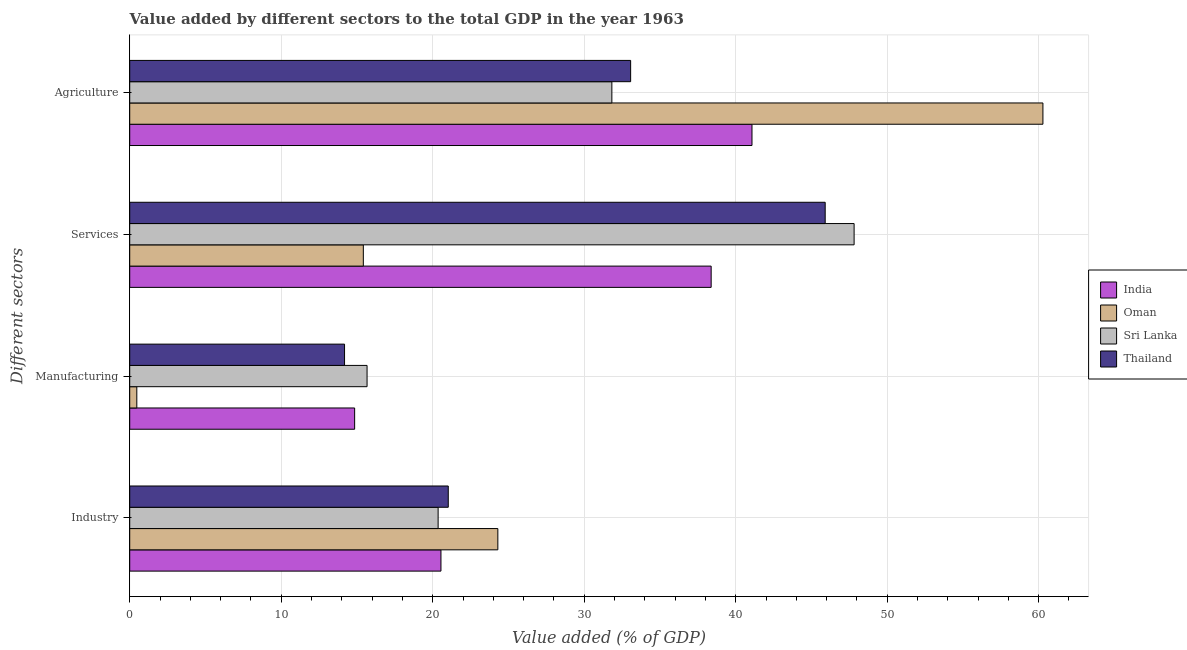How many different coloured bars are there?
Provide a short and direct response. 4. Are the number of bars on each tick of the Y-axis equal?
Give a very brief answer. Yes. How many bars are there on the 4th tick from the top?
Provide a succinct answer. 4. What is the label of the 1st group of bars from the top?
Your response must be concise. Agriculture. What is the value added by manufacturing sector in Thailand?
Keep it short and to the point. 14.18. Across all countries, what is the maximum value added by services sector?
Make the answer very short. 47.82. Across all countries, what is the minimum value added by manufacturing sector?
Your answer should be very brief. 0.47. In which country was the value added by industrial sector maximum?
Your response must be concise. Oman. In which country was the value added by agricultural sector minimum?
Offer a very short reply. Sri Lanka. What is the total value added by manufacturing sector in the graph?
Offer a terse response. 45.16. What is the difference between the value added by industrial sector in India and that in Oman?
Keep it short and to the point. -3.76. What is the difference between the value added by services sector in Thailand and the value added by industrial sector in India?
Your response must be concise. 25.36. What is the average value added by services sector per country?
Keep it short and to the point. 36.88. What is the difference between the value added by manufacturing sector and value added by industrial sector in India?
Your response must be concise. -5.7. What is the ratio of the value added by industrial sector in Thailand to that in Oman?
Provide a short and direct response. 0.87. Is the value added by services sector in Thailand less than that in India?
Offer a very short reply. No. Is the difference between the value added by industrial sector in Thailand and Oman greater than the difference between the value added by services sector in Thailand and Oman?
Make the answer very short. No. What is the difference between the highest and the second highest value added by services sector?
Your response must be concise. 1.91. What is the difference between the highest and the lowest value added by industrial sector?
Give a very brief answer. 3.94. Is it the case that in every country, the sum of the value added by manufacturing sector and value added by industrial sector is greater than the sum of value added by services sector and value added by agricultural sector?
Your response must be concise. No. What does the 3rd bar from the top in Agriculture represents?
Keep it short and to the point. Oman. What does the 3rd bar from the bottom in Agriculture represents?
Keep it short and to the point. Sri Lanka. How many bars are there?
Make the answer very short. 16. Are all the bars in the graph horizontal?
Offer a terse response. Yes. Are the values on the major ticks of X-axis written in scientific E-notation?
Provide a short and direct response. No. Does the graph contain any zero values?
Provide a short and direct response. No. Does the graph contain grids?
Make the answer very short. Yes. How are the legend labels stacked?
Give a very brief answer. Vertical. What is the title of the graph?
Provide a short and direct response. Value added by different sectors to the total GDP in the year 1963. What is the label or title of the X-axis?
Ensure brevity in your answer.  Value added (% of GDP). What is the label or title of the Y-axis?
Offer a terse response. Different sectors. What is the Value added (% of GDP) in India in Industry?
Provide a succinct answer. 20.54. What is the Value added (% of GDP) in Oman in Industry?
Provide a short and direct response. 24.3. What is the Value added (% of GDP) of Sri Lanka in Industry?
Offer a terse response. 20.36. What is the Value added (% of GDP) in Thailand in Industry?
Make the answer very short. 21.03. What is the Value added (% of GDP) in India in Manufacturing?
Provide a succinct answer. 14.85. What is the Value added (% of GDP) of Oman in Manufacturing?
Your answer should be very brief. 0.47. What is the Value added (% of GDP) in Sri Lanka in Manufacturing?
Your answer should be compact. 15.67. What is the Value added (% of GDP) of Thailand in Manufacturing?
Your answer should be compact. 14.18. What is the Value added (% of GDP) in India in Services?
Your answer should be compact. 38.38. What is the Value added (% of GDP) of Oman in Services?
Keep it short and to the point. 15.42. What is the Value added (% of GDP) of Sri Lanka in Services?
Offer a very short reply. 47.82. What is the Value added (% of GDP) of Thailand in Services?
Your answer should be compact. 45.91. What is the Value added (% of GDP) of India in Agriculture?
Keep it short and to the point. 41.08. What is the Value added (% of GDP) of Oman in Agriculture?
Offer a terse response. 60.28. What is the Value added (% of GDP) in Sri Lanka in Agriculture?
Offer a very short reply. 31.83. What is the Value added (% of GDP) of Thailand in Agriculture?
Your answer should be very brief. 33.07. Across all Different sectors, what is the maximum Value added (% of GDP) of India?
Offer a terse response. 41.08. Across all Different sectors, what is the maximum Value added (% of GDP) in Oman?
Make the answer very short. 60.28. Across all Different sectors, what is the maximum Value added (% of GDP) in Sri Lanka?
Your answer should be compact. 47.82. Across all Different sectors, what is the maximum Value added (% of GDP) of Thailand?
Give a very brief answer. 45.91. Across all Different sectors, what is the minimum Value added (% of GDP) in India?
Ensure brevity in your answer.  14.85. Across all Different sectors, what is the minimum Value added (% of GDP) in Oman?
Provide a succinct answer. 0.47. Across all Different sectors, what is the minimum Value added (% of GDP) in Sri Lanka?
Ensure brevity in your answer.  15.67. Across all Different sectors, what is the minimum Value added (% of GDP) in Thailand?
Give a very brief answer. 14.18. What is the total Value added (% of GDP) in India in the graph?
Your response must be concise. 114.85. What is the total Value added (% of GDP) of Oman in the graph?
Offer a very short reply. 100.47. What is the total Value added (% of GDP) of Sri Lanka in the graph?
Offer a terse response. 115.67. What is the total Value added (% of GDP) in Thailand in the graph?
Provide a succinct answer. 114.18. What is the difference between the Value added (% of GDP) of India in Industry and that in Manufacturing?
Provide a succinct answer. 5.7. What is the difference between the Value added (% of GDP) of Oman in Industry and that in Manufacturing?
Provide a succinct answer. 23.83. What is the difference between the Value added (% of GDP) in Sri Lanka in Industry and that in Manufacturing?
Ensure brevity in your answer.  4.69. What is the difference between the Value added (% of GDP) in Thailand in Industry and that in Manufacturing?
Provide a succinct answer. 6.85. What is the difference between the Value added (% of GDP) of India in Industry and that in Services?
Your answer should be very brief. -17.84. What is the difference between the Value added (% of GDP) in Oman in Industry and that in Services?
Your answer should be very brief. 8.88. What is the difference between the Value added (% of GDP) in Sri Lanka in Industry and that in Services?
Ensure brevity in your answer.  -27.46. What is the difference between the Value added (% of GDP) in Thailand in Industry and that in Services?
Provide a short and direct response. -24.88. What is the difference between the Value added (% of GDP) of India in Industry and that in Agriculture?
Keep it short and to the point. -20.53. What is the difference between the Value added (% of GDP) in Oman in Industry and that in Agriculture?
Your response must be concise. -35.98. What is the difference between the Value added (% of GDP) of Sri Lanka in Industry and that in Agriculture?
Provide a short and direct response. -11.47. What is the difference between the Value added (% of GDP) in Thailand in Industry and that in Agriculture?
Make the answer very short. -12.04. What is the difference between the Value added (% of GDP) of India in Manufacturing and that in Services?
Make the answer very short. -23.53. What is the difference between the Value added (% of GDP) of Oman in Manufacturing and that in Services?
Make the answer very short. -14.95. What is the difference between the Value added (% of GDP) in Sri Lanka in Manufacturing and that in Services?
Give a very brief answer. -32.15. What is the difference between the Value added (% of GDP) in Thailand in Manufacturing and that in Services?
Give a very brief answer. -31.73. What is the difference between the Value added (% of GDP) in India in Manufacturing and that in Agriculture?
Give a very brief answer. -26.23. What is the difference between the Value added (% of GDP) of Oman in Manufacturing and that in Agriculture?
Ensure brevity in your answer.  -59.81. What is the difference between the Value added (% of GDP) in Sri Lanka in Manufacturing and that in Agriculture?
Your answer should be compact. -16.16. What is the difference between the Value added (% of GDP) in Thailand in Manufacturing and that in Agriculture?
Make the answer very short. -18.88. What is the difference between the Value added (% of GDP) of India in Services and that in Agriculture?
Offer a terse response. -2.7. What is the difference between the Value added (% of GDP) in Oman in Services and that in Agriculture?
Make the answer very short. -44.86. What is the difference between the Value added (% of GDP) of Sri Lanka in Services and that in Agriculture?
Your response must be concise. 15.99. What is the difference between the Value added (% of GDP) of Thailand in Services and that in Agriculture?
Give a very brief answer. 12.84. What is the difference between the Value added (% of GDP) of India in Industry and the Value added (% of GDP) of Oman in Manufacturing?
Ensure brevity in your answer.  20.08. What is the difference between the Value added (% of GDP) of India in Industry and the Value added (% of GDP) of Sri Lanka in Manufacturing?
Your answer should be compact. 4.88. What is the difference between the Value added (% of GDP) of India in Industry and the Value added (% of GDP) of Thailand in Manufacturing?
Give a very brief answer. 6.36. What is the difference between the Value added (% of GDP) in Oman in Industry and the Value added (% of GDP) in Sri Lanka in Manufacturing?
Make the answer very short. 8.63. What is the difference between the Value added (% of GDP) of Oman in Industry and the Value added (% of GDP) of Thailand in Manufacturing?
Your answer should be very brief. 10.12. What is the difference between the Value added (% of GDP) in Sri Lanka in Industry and the Value added (% of GDP) in Thailand in Manufacturing?
Offer a very short reply. 6.18. What is the difference between the Value added (% of GDP) of India in Industry and the Value added (% of GDP) of Oman in Services?
Offer a terse response. 5.12. What is the difference between the Value added (% of GDP) of India in Industry and the Value added (% of GDP) of Sri Lanka in Services?
Your response must be concise. -27.27. What is the difference between the Value added (% of GDP) in India in Industry and the Value added (% of GDP) in Thailand in Services?
Your answer should be very brief. -25.36. What is the difference between the Value added (% of GDP) of Oman in Industry and the Value added (% of GDP) of Sri Lanka in Services?
Provide a succinct answer. -23.52. What is the difference between the Value added (% of GDP) in Oman in Industry and the Value added (% of GDP) in Thailand in Services?
Give a very brief answer. -21.61. What is the difference between the Value added (% of GDP) of Sri Lanka in Industry and the Value added (% of GDP) of Thailand in Services?
Your response must be concise. -25.55. What is the difference between the Value added (% of GDP) in India in Industry and the Value added (% of GDP) in Oman in Agriculture?
Your answer should be very brief. -39.74. What is the difference between the Value added (% of GDP) in India in Industry and the Value added (% of GDP) in Sri Lanka in Agriculture?
Your answer should be very brief. -11.28. What is the difference between the Value added (% of GDP) of India in Industry and the Value added (% of GDP) of Thailand in Agriculture?
Keep it short and to the point. -12.52. What is the difference between the Value added (% of GDP) in Oman in Industry and the Value added (% of GDP) in Sri Lanka in Agriculture?
Make the answer very short. -7.53. What is the difference between the Value added (% of GDP) in Oman in Industry and the Value added (% of GDP) in Thailand in Agriculture?
Ensure brevity in your answer.  -8.77. What is the difference between the Value added (% of GDP) in Sri Lanka in Industry and the Value added (% of GDP) in Thailand in Agriculture?
Your answer should be very brief. -12.71. What is the difference between the Value added (% of GDP) of India in Manufacturing and the Value added (% of GDP) of Oman in Services?
Give a very brief answer. -0.57. What is the difference between the Value added (% of GDP) of India in Manufacturing and the Value added (% of GDP) of Sri Lanka in Services?
Provide a succinct answer. -32.97. What is the difference between the Value added (% of GDP) in India in Manufacturing and the Value added (% of GDP) in Thailand in Services?
Your response must be concise. -31.06. What is the difference between the Value added (% of GDP) in Oman in Manufacturing and the Value added (% of GDP) in Sri Lanka in Services?
Offer a terse response. -47.35. What is the difference between the Value added (% of GDP) in Oman in Manufacturing and the Value added (% of GDP) in Thailand in Services?
Offer a terse response. -45.44. What is the difference between the Value added (% of GDP) in Sri Lanka in Manufacturing and the Value added (% of GDP) in Thailand in Services?
Your answer should be very brief. -30.24. What is the difference between the Value added (% of GDP) in India in Manufacturing and the Value added (% of GDP) in Oman in Agriculture?
Offer a terse response. -45.43. What is the difference between the Value added (% of GDP) in India in Manufacturing and the Value added (% of GDP) in Sri Lanka in Agriculture?
Provide a succinct answer. -16.98. What is the difference between the Value added (% of GDP) in India in Manufacturing and the Value added (% of GDP) in Thailand in Agriculture?
Give a very brief answer. -18.22. What is the difference between the Value added (% of GDP) in Oman in Manufacturing and the Value added (% of GDP) in Sri Lanka in Agriculture?
Offer a very short reply. -31.36. What is the difference between the Value added (% of GDP) of Oman in Manufacturing and the Value added (% of GDP) of Thailand in Agriculture?
Offer a very short reply. -32.6. What is the difference between the Value added (% of GDP) in Sri Lanka in Manufacturing and the Value added (% of GDP) in Thailand in Agriculture?
Make the answer very short. -17.4. What is the difference between the Value added (% of GDP) in India in Services and the Value added (% of GDP) in Oman in Agriculture?
Provide a succinct answer. -21.9. What is the difference between the Value added (% of GDP) in India in Services and the Value added (% of GDP) in Sri Lanka in Agriculture?
Keep it short and to the point. 6.55. What is the difference between the Value added (% of GDP) of India in Services and the Value added (% of GDP) of Thailand in Agriculture?
Your answer should be compact. 5.32. What is the difference between the Value added (% of GDP) of Oman in Services and the Value added (% of GDP) of Sri Lanka in Agriculture?
Offer a very short reply. -16.41. What is the difference between the Value added (% of GDP) in Oman in Services and the Value added (% of GDP) in Thailand in Agriculture?
Offer a terse response. -17.64. What is the difference between the Value added (% of GDP) in Sri Lanka in Services and the Value added (% of GDP) in Thailand in Agriculture?
Your answer should be compact. 14.75. What is the average Value added (% of GDP) of India per Different sectors?
Keep it short and to the point. 28.71. What is the average Value added (% of GDP) of Oman per Different sectors?
Your answer should be compact. 25.12. What is the average Value added (% of GDP) in Sri Lanka per Different sectors?
Ensure brevity in your answer.  28.92. What is the average Value added (% of GDP) of Thailand per Different sectors?
Your answer should be compact. 28.55. What is the difference between the Value added (% of GDP) of India and Value added (% of GDP) of Oman in Industry?
Your answer should be very brief. -3.76. What is the difference between the Value added (% of GDP) in India and Value added (% of GDP) in Sri Lanka in Industry?
Provide a short and direct response. 0.19. What is the difference between the Value added (% of GDP) in India and Value added (% of GDP) in Thailand in Industry?
Offer a terse response. -0.48. What is the difference between the Value added (% of GDP) of Oman and Value added (% of GDP) of Sri Lanka in Industry?
Make the answer very short. 3.94. What is the difference between the Value added (% of GDP) of Oman and Value added (% of GDP) of Thailand in Industry?
Offer a very short reply. 3.27. What is the difference between the Value added (% of GDP) in Sri Lanka and Value added (% of GDP) in Thailand in Industry?
Ensure brevity in your answer.  -0.67. What is the difference between the Value added (% of GDP) in India and Value added (% of GDP) in Oman in Manufacturing?
Ensure brevity in your answer.  14.38. What is the difference between the Value added (% of GDP) of India and Value added (% of GDP) of Sri Lanka in Manufacturing?
Offer a terse response. -0.82. What is the difference between the Value added (% of GDP) of India and Value added (% of GDP) of Thailand in Manufacturing?
Your answer should be compact. 0.67. What is the difference between the Value added (% of GDP) in Oman and Value added (% of GDP) in Sri Lanka in Manufacturing?
Your answer should be compact. -15.2. What is the difference between the Value added (% of GDP) of Oman and Value added (% of GDP) of Thailand in Manufacturing?
Provide a short and direct response. -13.71. What is the difference between the Value added (% of GDP) in Sri Lanka and Value added (% of GDP) in Thailand in Manufacturing?
Offer a terse response. 1.49. What is the difference between the Value added (% of GDP) in India and Value added (% of GDP) in Oman in Services?
Give a very brief answer. 22.96. What is the difference between the Value added (% of GDP) of India and Value added (% of GDP) of Sri Lanka in Services?
Keep it short and to the point. -9.44. What is the difference between the Value added (% of GDP) in India and Value added (% of GDP) in Thailand in Services?
Your answer should be very brief. -7.53. What is the difference between the Value added (% of GDP) in Oman and Value added (% of GDP) in Sri Lanka in Services?
Your response must be concise. -32.4. What is the difference between the Value added (% of GDP) in Oman and Value added (% of GDP) in Thailand in Services?
Provide a succinct answer. -30.49. What is the difference between the Value added (% of GDP) in Sri Lanka and Value added (% of GDP) in Thailand in Services?
Provide a short and direct response. 1.91. What is the difference between the Value added (% of GDP) of India and Value added (% of GDP) of Oman in Agriculture?
Keep it short and to the point. -19.2. What is the difference between the Value added (% of GDP) of India and Value added (% of GDP) of Sri Lanka in Agriculture?
Provide a succinct answer. 9.25. What is the difference between the Value added (% of GDP) in India and Value added (% of GDP) in Thailand in Agriculture?
Ensure brevity in your answer.  8.01. What is the difference between the Value added (% of GDP) in Oman and Value added (% of GDP) in Sri Lanka in Agriculture?
Ensure brevity in your answer.  28.45. What is the difference between the Value added (% of GDP) in Oman and Value added (% of GDP) in Thailand in Agriculture?
Provide a short and direct response. 27.21. What is the difference between the Value added (% of GDP) in Sri Lanka and Value added (% of GDP) in Thailand in Agriculture?
Your answer should be very brief. -1.24. What is the ratio of the Value added (% of GDP) in India in Industry to that in Manufacturing?
Offer a terse response. 1.38. What is the ratio of the Value added (% of GDP) of Sri Lanka in Industry to that in Manufacturing?
Your answer should be very brief. 1.3. What is the ratio of the Value added (% of GDP) in Thailand in Industry to that in Manufacturing?
Offer a terse response. 1.48. What is the ratio of the Value added (% of GDP) of India in Industry to that in Services?
Your response must be concise. 0.54. What is the ratio of the Value added (% of GDP) of Oman in Industry to that in Services?
Ensure brevity in your answer.  1.58. What is the ratio of the Value added (% of GDP) of Sri Lanka in Industry to that in Services?
Offer a very short reply. 0.43. What is the ratio of the Value added (% of GDP) of Thailand in Industry to that in Services?
Provide a short and direct response. 0.46. What is the ratio of the Value added (% of GDP) in India in Industry to that in Agriculture?
Provide a short and direct response. 0.5. What is the ratio of the Value added (% of GDP) of Oman in Industry to that in Agriculture?
Ensure brevity in your answer.  0.4. What is the ratio of the Value added (% of GDP) in Sri Lanka in Industry to that in Agriculture?
Ensure brevity in your answer.  0.64. What is the ratio of the Value added (% of GDP) of Thailand in Industry to that in Agriculture?
Your answer should be compact. 0.64. What is the ratio of the Value added (% of GDP) in India in Manufacturing to that in Services?
Provide a short and direct response. 0.39. What is the ratio of the Value added (% of GDP) of Oman in Manufacturing to that in Services?
Offer a very short reply. 0.03. What is the ratio of the Value added (% of GDP) of Sri Lanka in Manufacturing to that in Services?
Your answer should be very brief. 0.33. What is the ratio of the Value added (% of GDP) in Thailand in Manufacturing to that in Services?
Your response must be concise. 0.31. What is the ratio of the Value added (% of GDP) in India in Manufacturing to that in Agriculture?
Make the answer very short. 0.36. What is the ratio of the Value added (% of GDP) in Oman in Manufacturing to that in Agriculture?
Keep it short and to the point. 0.01. What is the ratio of the Value added (% of GDP) in Sri Lanka in Manufacturing to that in Agriculture?
Your response must be concise. 0.49. What is the ratio of the Value added (% of GDP) in Thailand in Manufacturing to that in Agriculture?
Your answer should be compact. 0.43. What is the ratio of the Value added (% of GDP) of India in Services to that in Agriculture?
Give a very brief answer. 0.93. What is the ratio of the Value added (% of GDP) in Oman in Services to that in Agriculture?
Your answer should be very brief. 0.26. What is the ratio of the Value added (% of GDP) in Sri Lanka in Services to that in Agriculture?
Your answer should be compact. 1.5. What is the ratio of the Value added (% of GDP) in Thailand in Services to that in Agriculture?
Make the answer very short. 1.39. What is the difference between the highest and the second highest Value added (% of GDP) of India?
Your response must be concise. 2.7. What is the difference between the highest and the second highest Value added (% of GDP) of Oman?
Ensure brevity in your answer.  35.98. What is the difference between the highest and the second highest Value added (% of GDP) in Sri Lanka?
Make the answer very short. 15.99. What is the difference between the highest and the second highest Value added (% of GDP) of Thailand?
Provide a short and direct response. 12.84. What is the difference between the highest and the lowest Value added (% of GDP) of India?
Keep it short and to the point. 26.23. What is the difference between the highest and the lowest Value added (% of GDP) of Oman?
Your answer should be compact. 59.81. What is the difference between the highest and the lowest Value added (% of GDP) in Sri Lanka?
Provide a succinct answer. 32.15. What is the difference between the highest and the lowest Value added (% of GDP) in Thailand?
Your answer should be compact. 31.73. 